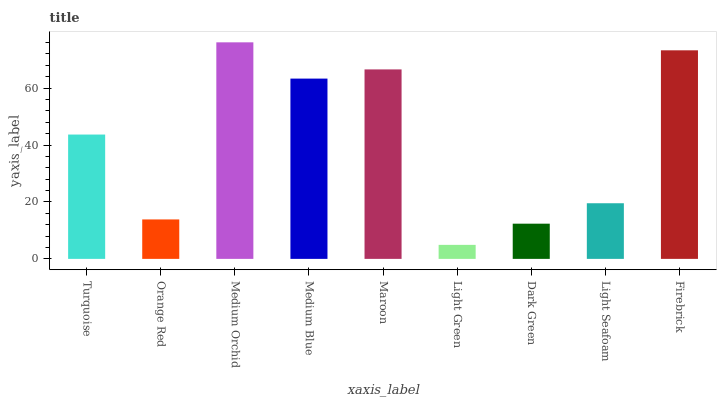Is Light Green the minimum?
Answer yes or no. Yes. Is Medium Orchid the maximum?
Answer yes or no. Yes. Is Orange Red the minimum?
Answer yes or no. No. Is Orange Red the maximum?
Answer yes or no. No. Is Turquoise greater than Orange Red?
Answer yes or no. Yes. Is Orange Red less than Turquoise?
Answer yes or no. Yes. Is Orange Red greater than Turquoise?
Answer yes or no. No. Is Turquoise less than Orange Red?
Answer yes or no. No. Is Turquoise the high median?
Answer yes or no. Yes. Is Turquoise the low median?
Answer yes or no. Yes. Is Light Seafoam the high median?
Answer yes or no. No. Is Firebrick the low median?
Answer yes or no. No. 